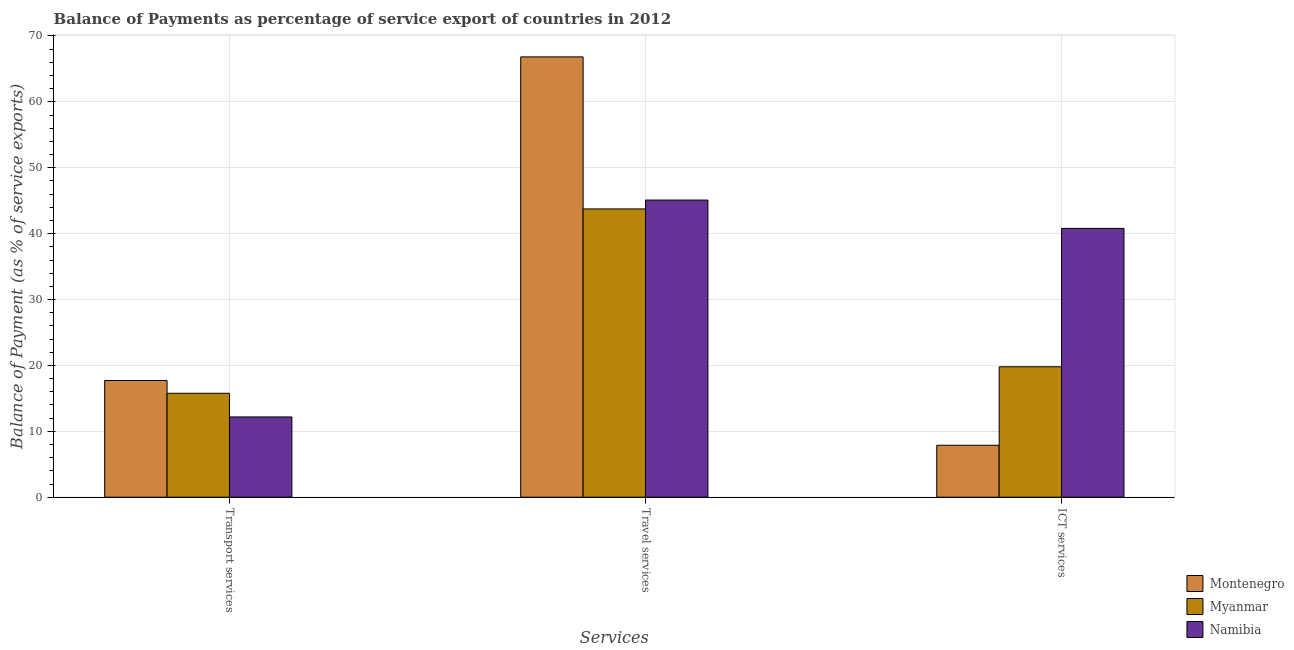Are the number of bars per tick equal to the number of legend labels?
Offer a terse response. Yes. How many bars are there on the 2nd tick from the right?
Offer a terse response. 3. What is the label of the 1st group of bars from the left?
Provide a short and direct response. Transport services. What is the balance of payment of transport services in Namibia?
Give a very brief answer. 12.18. Across all countries, what is the maximum balance of payment of travel services?
Offer a terse response. 66.82. Across all countries, what is the minimum balance of payment of transport services?
Provide a succinct answer. 12.18. In which country was the balance of payment of travel services maximum?
Your response must be concise. Montenegro. In which country was the balance of payment of ict services minimum?
Provide a short and direct response. Montenegro. What is the total balance of payment of travel services in the graph?
Provide a succinct answer. 155.67. What is the difference between the balance of payment of travel services in Montenegro and that in Myanmar?
Your answer should be very brief. 23.07. What is the difference between the balance of payment of travel services in Montenegro and the balance of payment of transport services in Myanmar?
Provide a succinct answer. 51.05. What is the average balance of payment of transport services per country?
Provide a succinct answer. 15.22. What is the difference between the balance of payment of transport services and balance of payment of travel services in Myanmar?
Provide a short and direct response. -27.98. In how many countries, is the balance of payment of ict services greater than 26 %?
Your answer should be compact. 1. What is the ratio of the balance of payment of travel services in Montenegro to that in Myanmar?
Offer a very short reply. 1.53. What is the difference between the highest and the second highest balance of payment of travel services?
Offer a very short reply. 21.73. What is the difference between the highest and the lowest balance of payment of transport services?
Provide a succinct answer. 5.53. In how many countries, is the balance of payment of travel services greater than the average balance of payment of travel services taken over all countries?
Ensure brevity in your answer.  1. Is the sum of the balance of payment of ict services in Namibia and Myanmar greater than the maximum balance of payment of travel services across all countries?
Your answer should be very brief. No. What does the 1st bar from the left in Transport services represents?
Offer a terse response. Montenegro. What does the 3rd bar from the right in ICT services represents?
Ensure brevity in your answer.  Montenegro. How many bars are there?
Your response must be concise. 9. Does the graph contain any zero values?
Keep it short and to the point. No. Does the graph contain grids?
Offer a very short reply. Yes. What is the title of the graph?
Make the answer very short. Balance of Payments as percentage of service export of countries in 2012. What is the label or title of the X-axis?
Your answer should be compact. Services. What is the label or title of the Y-axis?
Your response must be concise. Balance of Payment (as % of service exports). What is the Balance of Payment (as % of service exports) in Montenegro in Transport services?
Offer a terse response. 17.71. What is the Balance of Payment (as % of service exports) in Myanmar in Transport services?
Provide a succinct answer. 15.77. What is the Balance of Payment (as % of service exports) of Namibia in Transport services?
Make the answer very short. 12.18. What is the Balance of Payment (as % of service exports) of Montenegro in Travel services?
Provide a short and direct response. 66.82. What is the Balance of Payment (as % of service exports) in Myanmar in Travel services?
Provide a succinct answer. 43.75. What is the Balance of Payment (as % of service exports) of Namibia in Travel services?
Keep it short and to the point. 45.1. What is the Balance of Payment (as % of service exports) of Montenegro in ICT services?
Provide a succinct answer. 7.88. What is the Balance of Payment (as % of service exports) in Myanmar in ICT services?
Your answer should be compact. 19.79. What is the Balance of Payment (as % of service exports) in Namibia in ICT services?
Your answer should be very brief. 40.79. Across all Services, what is the maximum Balance of Payment (as % of service exports) of Montenegro?
Offer a very short reply. 66.82. Across all Services, what is the maximum Balance of Payment (as % of service exports) of Myanmar?
Make the answer very short. 43.75. Across all Services, what is the maximum Balance of Payment (as % of service exports) of Namibia?
Your response must be concise. 45.1. Across all Services, what is the minimum Balance of Payment (as % of service exports) of Montenegro?
Your response must be concise. 7.88. Across all Services, what is the minimum Balance of Payment (as % of service exports) of Myanmar?
Provide a short and direct response. 15.77. Across all Services, what is the minimum Balance of Payment (as % of service exports) in Namibia?
Keep it short and to the point. 12.18. What is the total Balance of Payment (as % of service exports) of Montenegro in the graph?
Provide a short and direct response. 92.42. What is the total Balance of Payment (as % of service exports) in Myanmar in the graph?
Your answer should be very brief. 79.32. What is the total Balance of Payment (as % of service exports) in Namibia in the graph?
Provide a short and direct response. 98.07. What is the difference between the Balance of Payment (as % of service exports) in Montenegro in Transport services and that in Travel services?
Ensure brevity in your answer.  -49.11. What is the difference between the Balance of Payment (as % of service exports) in Myanmar in Transport services and that in Travel services?
Provide a short and direct response. -27.98. What is the difference between the Balance of Payment (as % of service exports) of Namibia in Transport services and that in Travel services?
Make the answer very short. -32.91. What is the difference between the Balance of Payment (as % of service exports) of Montenegro in Transport services and that in ICT services?
Ensure brevity in your answer.  9.83. What is the difference between the Balance of Payment (as % of service exports) in Myanmar in Transport services and that in ICT services?
Give a very brief answer. -4.02. What is the difference between the Balance of Payment (as % of service exports) in Namibia in Transport services and that in ICT services?
Your answer should be compact. -28.61. What is the difference between the Balance of Payment (as % of service exports) in Montenegro in Travel services and that in ICT services?
Make the answer very short. 58.94. What is the difference between the Balance of Payment (as % of service exports) in Myanmar in Travel services and that in ICT services?
Provide a succinct answer. 23.96. What is the difference between the Balance of Payment (as % of service exports) of Namibia in Travel services and that in ICT services?
Offer a terse response. 4.3. What is the difference between the Balance of Payment (as % of service exports) of Montenegro in Transport services and the Balance of Payment (as % of service exports) of Myanmar in Travel services?
Your answer should be very brief. -26.04. What is the difference between the Balance of Payment (as % of service exports) of Montenegro in Transport services and the Balance of Payment (as % of service exports) of Namibia in Travel services?
Keep it short and to the point. -27.38. What is the difference between the Balance of Payment (as % of service exports) in Myanmar in Transport services and the Balance of Payment (as % of service exports) in Namibia in Travel services?
Ensure brevity in your answer.  -29.32. What is the difference between the Balance of Payment (as % of service exports) of Montenegro in Transport services and the Balance of Payment (as % of service exports) of Myanmar in ICT services?
Ensure brevity in your answer.  -2.08. What is the difference between the Balance of Payment (as % of service exports) of Montenegro in Transport services and the Balance of Payment (as % of service exports) of Namibia in ICT services?
Ensure brevity in your answer.  -23.08. What is the difference between the Balance of Payment (as % of service exports) in Myanmar in Transport services and the Balance of Payment (as % of service exports) in Namibia in ICT services?
Offer a very short reply. -25.02. What is the difference between the Balance of Payment (as % of service exports) of Montenegro in Travel services and the Balance of Payment (as % of service exports) of Myanmar in ICT services?
Offer a terse response. 47.03. What is the difference between the Balance of Payment (as % of service exports) of Montenegro in Travel services and the Balance of Payment (as % of service exports) of Namibia in ICT services?
Your response must be concise. 26.03. What is the difference between the Balance of Payment (as % of service exports) of Myanmar in Travel services and the Balance of Payment (as % of service exports) of Namibia in ICT services?
Provide a short and direct response. 2.96. What is the average Balance of Payment (as % of service exports) of Montenegro per Services?
Your answer should be very brief. 30.81. What is the average Balance of Payment (as % of service exports) in Myanmar per Services?
Offer a terse response. 26.44. What is the average Balance of Payment (as % of service exports) of Namibia per Services?
Your response must be concise. 32.69. What is the difference between the Balance of Payment (as % of service exports) in Montenegro and Balance of Payment (as % of service exports) in Myanmar in Transport services?
Your response must be concise. 1.94. What is the difference between the Balance of Payment (as % of service exports) of Montenegro and Balance of Payment (as % of service exports) of Namibia in Transport services?
Make the answer very short. 5.53. What is the difference between the Balance of Payment (as % of service exports) of Myanmar and Balance of Payment (as % of service exports) of Namibia in Transport services?
Provide a short and direct response. 3.59. What is the difference between the Balance of Payment (as % of service exports) in Montenegro and Balance of Payment (as % of service exports) in Myanmar in Travel services?
Provide a short and direct response. 23.07. What is the difference between the Balance of Payment (as % of service exports) of Montenegro and Balance of Payment (as % of service exports) of Namibia in Travel services?
Your answer should be compact. 21.73. What is the difference between the Balance of Payment (as % of service exports) of Myanmar and Balance of Payment (as % of service exports) of Namibia in Travel services?
Make the answer very short. -1.34. What is the difference between the Balance of Payment (as % of service exports) in Montenegro and Balance of Payment (as % of service exports) in Myanmar in ICT services?
Your response must be concise. -11.91. What is the difference between the Balance of Payment (as % of service exports) in Montenegro and Balance of Payment (as % of service exports) in Namibia in ICT services?
Ensure brevity in your answer.  -32.91. What is the difference between the Balance of Payment (as % of service exports) in Myanmar and Balance of Payment (as % of service exports) in Namibia in ICT services?
Offer a terse response. -21. What is the ratio of the Balance of Payment (as % of service exports) in Montenegro in Transport services to that in Travel services?
Ensure brevity in your answer.  0.27. What is the ratio of the Balance of Payment (as % of service exports) in Myanmar in Transport services to that in Travel services?
Your answer should be very brief. 0.36. What is the ratio of the Balance of Payment (as % of service exports) of Namibia in Transport services to that in Travel services?
Your answer should be very brief. 0.27. What is the ratio of the Balance of Payment (as % of service exports) of Montenegro in Transport services to that in ICT services?
Offer a terse response. 2.25. What is the ratio of the Balance of Payment (as % of service exports) in Myanmar in Transport services to that in ICT services?
Offer a terse response. 0.8. What is the ratio of the Balance of Payment (as % of service exports) of Namibia in Transport services to that in ICT services?
Offer a terse response. 0.3. What is the ratio of the Balance of Payment (as % of service exports) in Montenegro in Travel services to that in ICT services?
Make the answer very short. 8.48. What is the ratio of the Balance of Payment (as % of service exports) in Myanmar in Travel services to that in ICT services?
Ensure brevity in your answer.  2.21. What is the ratio of the Balance of Payment (as % of service exports) of Namibia in Travel services to that in ICT services?
Keep it short and to the point. 1.11. What is the difference between the highest and the second highest Balance of Payment (as % of service exports) of Montenegro?
Your answer should be compact. 49.11. What is the difference between the highest and the second highest Balance of Payment (as % of service exports) in Myanmar?
Your response must be concise. 23.96. What is the difference between the highest and the second highest Balance of Payment (as % of service exports) of Namibia?
Offer a terse response. 4.3. What is the difference between the highest and the lowest Balance of Payment (as % of service exports) in Montenegro?
Give a very brief answer. 58.94. What is the difference between the highest and the lowest Balance of Payment (as % of service exports) of Myanmar?
Make the answer very short. 27.98. What is the difference between the highest and the lowest Balance of Payment (as % of service exports) of Namibia?
Ensure brevity in your answer.  32.91. 